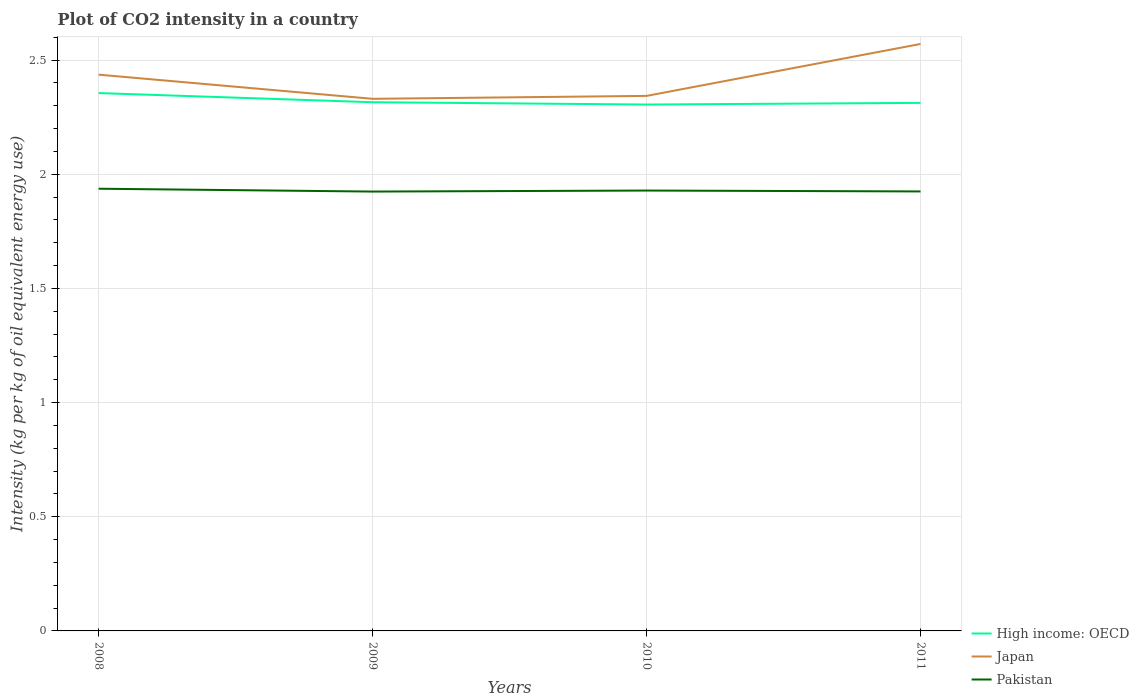Is the number of lines equal to the number of legend labels?
Ensure brevity in your answer.  Yes. Across all years, what is the maximum CO2 intensity in in Japan?
Your answer should be compact. 2.33. What is the total CO2 intensity in in Pakistan in the graph?
Your response must be concise. -0. What is the difference between the highest and the second highest CO2 intensity in in High income: OECD?
Provide a succinct answer. 0.05. What is the difference between the highest and the lowest CO2 intensity in in Japan?
Keep it short and to the point. 2. Is the CO2 intensity in in High income: OECD strictly greater than the CO2 intensity in in Pakistan over the years?
Your answer should be very brief. No. How many lines are there?
Your response must be concise. 3. How many years are there in the graph?
Make the answer very short. 4. What is the difference between two consecutive major ticks on the Y-axis?
Offer a very short reply. 0.5. Does the graph contain grids?
Your answer should be compact. Yes. How many legend labels are there?
Your response must be concise. 3. What is the title of the graph?
Offer a very short reply. Plot of CO2 intensity in a country. Does "Burundi" appear as one of the legend labels in the graph?
Give a very brief answer. No. What is the label or title of the Y-axis?
Provide a succinct answer. Intensity (kg per kg of oil equivalent energy use). What is the Intensity (kg per kg of oil equivalent energy use) of High income: OECD in 2008?
Provide a succinct answer. 2.36. What is the Intensity (kg per kg of oil equivalent energy use) in Japan in 2008?
Provide a short and direct response. 2.44. What is the Intensity (kg per kg of oil equivalent energy use) of Pakistan in 2008?
Give a very brief answer. 1.94. What is the Intensity (kg per kg of oil equivalent energy use) in High income: OECD in 2009?
Keep it short and to the point. 2.32. What is the Intensity (kg per kg of oil equivalent energy use) of Japan in 2009?
Offer a very short reply. 2.33. What is the Intensity (kg per kg of oil equivalent energy use) of Pakistan in 2009?
Offer a terse response. 1.92. What is the Intensity (kg per kg of oil equivalent energy use) in High income: OECD in 2010?
Make the answer very short. 2.31. What is the Intensity (kg per kg of oil equivalent energy use) of Japan in 2010?
Offer a very short reply. 2.34. What is the Intensity (kg per kg of oil equivalent energy use) in Pakistan in 2010?
Your answer should be very brief. 1.93. What is the Intensity (kg per kg of oil equivalent energy use) of High income: OECD in 2011?
Offer a very short reply. 2.31. What is the Intensity (kg per kg of oil equivalent energy use) of Japan in 2011?
Your answer should be very brief. 2.57. What is the Intensity (kg per kg of oil equivalent energy use) of Pakistan in 2011?
Give a very brief answer. 1.92. Across all years, what is the maximum Intensity (kg per kg of oil equivalent energy use) in High income: OECD?
Ensure brevity in your answer.  2.36. Across all years, what is the maximum Intensity (kg per kg of oil equivalent energy use) in Japan?
Offer a terse response. 2.57. Across all years, what is the maximum Intensity (kg per kg of oil equivalent energy use) of Pakistan?
Offer a terse response. 1.94. Across all years, what is the minimum Intensity (kg per kg of oil equivalent energy use) in High income: OECD?
Give a very brief answer. 2.31. Across all years, what is the minimum Intensity (kg per kg of oil equivalent energy use) in Japan?
Ensure brevity in your answer.  2.33. Across all years, what is the minimum Intensity (kg per kg of oil equivalent energy use) of Pakistan?
Give a very brief answer. 1.92. What is the total Intensity (kg per kg of oil equivalent energy use) in High income: OECD in the graph?
Your answer should be compact. 9.29. What is the total Intensity (kg per kg of oil equivalent energy use) of Japan in the graph?
Your answer should be very brief. 9.68. What is the total Intensity (kg per kg of oil equivalent energy use) of Pakistan in the graph?
Provide a succinct answer. 7.71. What is the difference between the Intensity (kg per kg of oil equivalent energy use) in High income: OECD in 2008 and that in 2009?
Give a very brief answer. 0.04. What is the difference between the Intensity (kg per kg of oil equivalent energy use) of Japan in 2008 and that in 2009?
Make the answer very short. 0.11. What is the difference between the Intensity (kg per kg of oil equivalent energy use) in Pakistan in 2008 and that in 2009?
Provide a succinct answer. 0.01. What is the difference between the Intensity (kg per kg of oil equivalent energy use) in High income: OECD in 2008 and that in 2010?
Ensure brevity in your answer.  0.05. What is the difference between the Intensity (kg per kg of oil equivalent energy use) of Japan in 2008 and that in 2010?
Give a very brief answer. 0.09. What is the difference between the Intensity (kg per kg of oil equivalent energy use) of Pakistan in 2008 and that in 2010?
Your answer should be compact. 0.01. What is the difference between the Intensity (kg per kg of oil equivalent energy use) of High income: OECD in 2008 and that in 2011?
Keep it short and to the point. 0.04. What is the difference between the Intensity (kg per kg of oil equivalent energy use) of Japan in 2008 and that in 2011?
Ensure brevity in your answer.  -0.13. What is the difference between the Intensity (kg per kg of oil equivalent energy use) in Pakistan in 2008 and that in 2011?
Offer a very short reply. 0.01. What is the difference between the Intensity (kg per kg of oil equivalent energy use) of High income: OECD in 2009 and that in 2010?
Keep it short and to the point. 0.01. What is the difference between the Intensity (kg per kg of oil equivalent energy use) in Japan in 2009 and that in 2010?
Provide a succinct answer. -0.01. What is the difference between the Intensity (kg per kg of oil equivalent energy use) in Pakistan in 2009 and that in 2010?
Provide a succinct answer. -0. What is the difference between the Intensity (kg per kg of oil equivalent energy use) of High income: OECD in 2009 and that in 2011?
Provide a short and direct response. 0. What is the difference between the Intensity (kg per kg of oil equivalent energy use) in Japan in 2009 and that in 2011?
Give a very brief answer. -0.24. What is the difference between the Intensity (kg per kg of oil equivalent energy use) in Pakistan in 2009 and that in 2011?
Give a very brief answer. -0. What is the difference between the Intensity (kg per kg of oil equivalent energy use) of High income: OECD in 2010 and that in 2011?
Give a very brief answer. -0.01. What is the difference between the Intensity (kg per kg of oil equivalent energy use) of Japan in 2010 and that in 2011?
Your answer should be very brief. -0.23. What is the difference between the Intensity (kg per kg of oil equivalent energy use) of Pakistan in 2010 and that in 2011?
Offer a very short reply. 0. What is the difference between the Intensity (kg per kg of oil equivalent energy use) in High income: OECD in 2008 and the Intensity (kg per kg of oil equivalent energy use) in Japan in 2009?
Give a very brief answer. 0.03. What is the difference between the Intensity (kg per kg of oil equivalent energy use) in High income: OECD in 2008 and the Intensity (kg per kg of oil equivalent energy use) in Pakistan in 2009?
Make the answer very short. 0.43. What is the difference between the Intensity (kg per kg of oil equivalent energy use) in Japan in 2008 and the Intensity (kg per kg of oil equivalent energy use) in Pakistan in 2009?
Provide a succinct answer. 0.51. What is the difference between the Intensity (kg per kg of oil equivalent energy use) in High income: OECD in 2008 and the Intensity (kg per kg of oil equivalent energy use) in Japan in 2010?
Ensure brevity in your answer.  0.01. What is the difference between the Intensity (kg per kg of oil equivalent energy use) of High income: OECD in 2008 and the Intensity (kg per kg of oil equivalent energy use) of Pakistan in 2010?
Make the answer very short. 0.43. What is the difference between the Intensity (kg per kg of oil equivalent energy use) of Japan in 2008 and the Intensity (kg per kg of oil equivalent energy use) of Pakistan in 2010?
Give a very brief answer. 0.51. What is the difference between the Intensity (kg per kg of oil equivalent energy use) of High income: OECD in 2008 and the Intensity (kg per kg of oil equivalent energy use) of Japan in 2011?
Provide a short and direct response. -0.22. What is the difference between the Intensity (kg per kg of oil equivalent energy use) of High income: OECD in 2008 and the Intensity (kg per kg of oil equivalent energy use) of Pakistan in 2011?
Give a very brief answer. 0.43. What is the difference between the Intensity (kg per kg of oil equivalent energy use) of Japan in 2008 and the Intensity (kg per kg of oil equivalent energy use) of Pakistan in 2011?
Give a very brief answer. 0.51. What is the difference between the Intensity (kg per kg of oil equivalent energy use) in High income: OECD in 2009 and the Intensity (kg per kg of oil equivalent energy use) in Japan in 2010?
Make the answer very short. -0.03. What is the difference between the Intensity (kg per kg of oil equivalent energy use) in High income: OECD in 2009 and the Intensity (kg per kg of oil equivalent energy use) in Pakistan in 2010?
Offer a terse response. 0.39. What is the difference between the Intensity (kg per kg of oil equivalent energy use) of Japan in 2009 and the Intensity (kg per kg of oil equivalent energy use) of Pakistan in 2010?
Your answer should be compact. 0.4. What is the difference between the Intensity (kg per kg of oil equivalent energy use) of High income: OECD in 2009 and the Intensity (kg per kg of oil equivalent energy use) of Japan in 2011?
Offer a terse response. -0.26. What is the difference between the Intensity (kg per kg of oil equivalent energy use) in High income: OECD in 2009 and the Intensity (kg per kg of oil equivalent energy use) in Pakistan in 2011?
Provide a succinct answer. 0.39. What is the difference between the Intensity (kg per kg of oil equivalent energy use) in Japan in 2009 and the Intensity (kg per kg of oil equivalent energy use) in Pakistan in 2011?
Offer a very short reply. 0.41. What is the difference between the Intensity (kg per kg of oil equivalent energy use) of High income: OECD in 2010 and the Intensity (kg per kg of oil equivalent energy use) of Japan in 2011?
Make the answer very short. -0.27. What is the difference between the Intensity (kg per kg of oil equivalent energy use) of High income: OECD in 2010 and the Intensity (kg per kg of oil equivalent energy use) of Pakistan in 2011?
Offer a terse response. 0.38. What is the difference between the Intensity (kg per kg of oil equivalent energy use) in Japan in 2010 and the Intensity (kg per kg of oil equivalent energy use) in Pakistan in 2011?
Provide a succinct answer. 0.42. What is the average Intensity (kg per kg of oil equivalent energy use) in High income: OECD per year?
Offer a very short reply. 2.32. What is the average Intensity (kg per kg of oil equivalent energy use) of Japan per year?
Your answer should be very brief. 2.42. What is the average Intensity (kg per kg of oil equivalent energy use) in Pakistan per year?
Your answer should be compact. 1.93. In the year 2008, what is the difference between the Intensity (kg per kg of oil equivalent energy use) in High income: OECD and Intensity (kg per kg of oil equivalent energy use) in Japan?
Offer a very short reply. -0.08. In the year 2008, what is the difference between the Intensity (kg per kg of oil equivalent energy use) in High income: OECD and Intensity (kg per kg of oil equivalent energy use) in Pakistan?
Offer a terse response. 0.42. In the year 2008, what is the difference between the Intensity (kg per kg of oil equivalent energy use) in Japan and Intensity (kg per kg of oil equivalent energy use) in Pakistan?
Offer a very short reply. 0.5. In the year 2009, what is the difference between the Intensity (kg per kg of oil equivalent energy use) of High income: OECD and Intensity (kg per kg of oil equivalent energy use) of Japan?
Provide a succinct answer. -0.01. In the year 2009, what is the difference between the Intensity (kg per kg of oil equivalent energy use) in High income: OECD and Intensity (kg per kg of oil equivalent energy use) in Pakistan?
Your answer should be very brief. 0.39. In the year 2009, what is the difference between the Intensity (kg per kg of oil equivalent energy use) of Japan and Intensity (kg per kg of oil equivalent energy use) of Pakistan?
Make the answer very short. 0.41. In the year 2010, what is the difference between the Intensity (kg per kg of oil equivalent energy use) of High income: OECD and Intensity (kg per kg of oil equivalent energy use) of Japan?
Your answer should be compact. -0.04. In the year 2010, what is the difference between the Intensity (kg per kg of oil equivalent energy use) in High income: OECD and Intensity (kg per kg of oil equivalent energy use) in Pakistan?
Your response must be concise. 0.38. In the year 2010, what is the difference between the Intensity (kg per kg of oil equivalent energy use) in Japan and Intensity (kg per kg of oil equivalent energy use) in Pakistan?
Your answer should be compact. 0.41. In the year 2011, what is the difference between the Intensity (kg per kg of oil equivalent energy use) in High income: OECD and Intensity (kg per kg of oil equivalent energy use) in Japan?
Ensure brevity in your answer.  -0.26. In the year 2011, what is the difference between the Intensity (kg per kg of oil equivalent energy use) of High income: OECD and Intensity (kg per kg of oil equivalent energy use) of Pakistan?
Your response must be concise. 0.39. In the year 2011, what is the difference between the Intensity (kg per kg of oil equivalent energy use) of Japan and Intensity (kg per kg of oil equivalent energy use) of Pakistan?
Make the answer very short. 0.65. What is the ratio of the Intensity (kg per kg of oil equivalent energy use) of High income: OECD in 2008 to that in 2009?
Your response must be concise. 1.02. What is the ratio of the Intensity (kg per kg of oil equivalent energy use) in Japan in 2008 to that in 2009?
Provide a short and direct response. 1.05. What is the ratio of the Intensity (kg per kg of oil equivalent energy use) in High income: OECD in 2008 to that in 2010?
Keep it short and to the point. 1.02. What is the ratio of the Intensity (kg per kg of oil equivalent energy use) of Japan in 2008 to that in 2010?
Give a very brief answer. 1.04. What is the ratio of the Intensity (kg per kg of oil equivalent energy use) in High income: OECD in 2008 to that in 2011?
Keep it short and to the point. 1.02. What is the ratio of the Intensity (kg per kg of oil equivalent energy use) in Japan in 2008 to that in 2011?
Give a very brief answer. 0.95. What is the ratio of the Intensity (kg per kg of oil equivalent energy use) in High income: OECD in 2009 to that in 2010?
Offer a terse response. 1. What is the ratio of the Intensity (kg per kg of oil equivalent energy use) in Japan in 2009 to that in 2010?
Ensure brevity in your answer.  0.99. What is the ratio of the Intensity (kg per kg of oil equivalent energy use) in Pakistan in 2009 to that in 2010?
Provide a succinct answer. 1. What is the ratio of the Intensity (kg per kg of oil equivalent energy use) of High income: OECD in 2009 to that in 2011?
Offer a very short reply. 1. What is the ratio of the Intensity (kg per kg of oil equivalent energy use) of Japan in 2009 to that in 2011?
Provide a succinct answer. 0.91. What is the ratio of the Intensity (kg per kg of oil equivalent energy use) in High income: OECD in 2010 to that in 2011?
Offer a terse response. 1. What is the ratio of the Intensity (kg per kg of oil equivalent energy use) of Japan in 2010 to that in 2011?
Ensure brevity in your answer.  0.91. What is the difference between the highest and the second highest Intensity (kg per kg of oil equivalent energy use) in High income: OECD?
Ensure brevity in your answer.  0.04. What is the difference between the highest and the second highest Intensity (kg per kg of oil equivalent energy use) of Japan?
Give a very brief answer. 0.13. What is the difference between the highest and the second highest Intensity (kg per kg of oil equivalent energy use) in Pakistan?
Offer a very short reply. 0.01. What is the difference between the highest and the lowest Intensity (kg per kg of oil equivalent energy use) in High income: OECD?
Give a very brief answer. 0.05. What is the difference between the highest and the lowest Intensity (kg per kg of oil equivalent energy use) in Japan?
Your response must be concise. 0.24. What is the difference between the highest and the lowest Intensity (kg per kg of oil equivalent energy use) of Pakistan?
Offer a terse response. 0.01. 